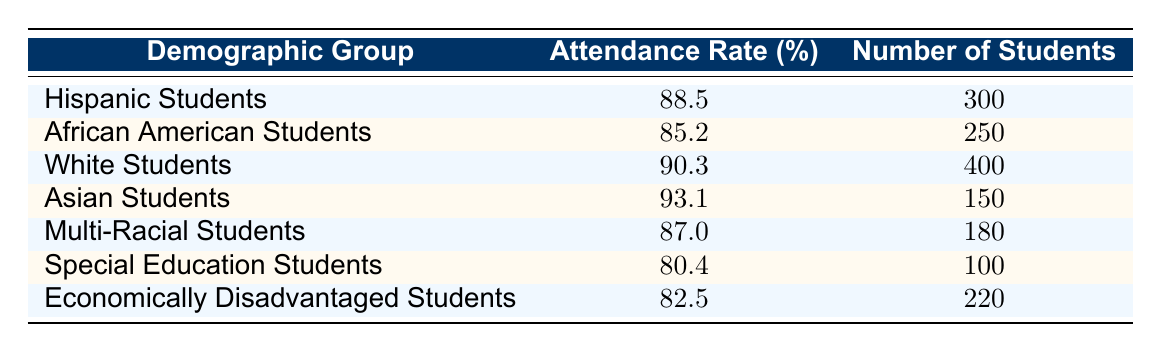What's the attendance rate for Asian Students? The attendance rate is a specific value in the table under the "Attendance Rate (%)" column for the row corresponding to "Asian Students". According to the table, the attendance rate for Asian Students is 93.1%.
Answer: 93.1 How many African American Students are there? The number of African American Students is listed in the "Number of Students" column for the row labeled "African American Students". The table indicates there are 250 African American Students.
Answer: 250 Which group has the highest attendance rate? To find the group with the highest attendance rate, compare all attendance rates presented in the table. The values are: 88.5 (Hispanic), 85.2 (African American), 90.3 (White), 93.1 (Asian), 87.0 (Multi-Racial), 80.4 (Special Education), and 82.5 (Economically Disadvantaged). The highest attendance rate is 93.1% for Asian Students.
Answer: Asian Students What is the average attendance rate for the listed demographic groups? To calculate the average attendance rate, sum all the attendance rates: 88.5 + 85.2 + 90.3 + 93.1 + 87.0 + 80.4 + 82.5 = 517.0. Divide the total by the number of groups, which is 7. So, 517.0 / 7 = 73.857. The average attendance rate is approximately 73.9%.
Answer: 73.9 Is the attendance rate for Economically Disadvantaged Students lower than that of Special Education Students? Compare the attendance rates for Economically Disadvantaged Students (82.5%) and Special Education Students (80.4%). Since 82.5% is greater than 80.4%, the statement is false.
Answer: No What is the difference in attendance rates between White Students and Multi-Racial Students? The attendance rate for White Students is 90.3% and for Multi-Racial Students it is 87.0%. To find the difference, subtract the Multi-Racial rate from the White rate: 90.3 - 87.0 = 3.3. The difference in attendance rates is 3.3%.
Answer: 3.3 Do more Hispanic Students attend school than Asian Students? The table shows there are 300 Hispanic Students and 150 Asian Students. Since 300 is greater than 150, the statement is true.
Answer: Yes What is the total number of students across all demographic groups? To find the total number of students, sum the "Number of Students" values: 300 (Hispanic) + 250 (African American) + 400 (White) + 150 (Asian) + 180 (Multi-Racial) + 100 (Special Education) + 220 (Economically Disadvantaged) = 1600. The total number of students is 1600.
Answer: 1600 Is the attendance rate for African American Students above 90%? The attendance rate for African American Students is 85.2%, which is below 90%. Therefore, the statement is false.
Answer: No 